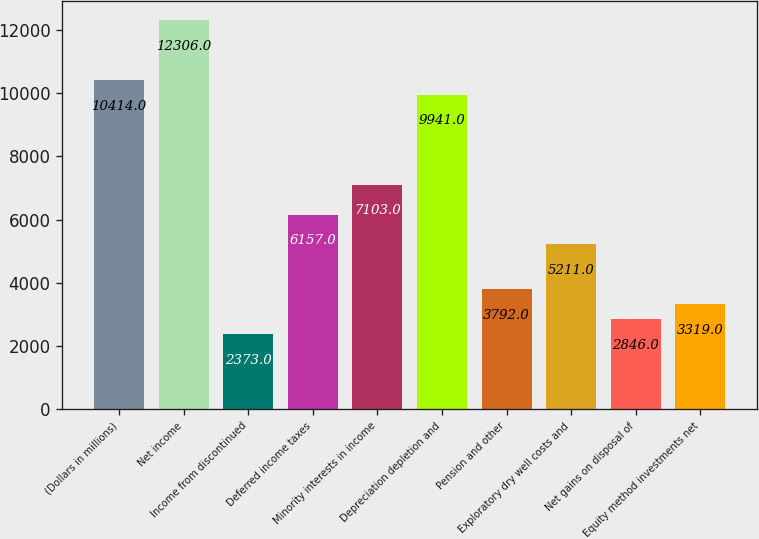Convert chart. <chart><loc_0><loc_0><loc_500><loc_500><bar_chart><fcel>(Dollars in millions)<fcel>Net income<fcel>Income from discontinued<fcel>Deferred income taxes<fcel>Minority interests in income<fcel>Depreciation depletion and<fcel>Pension and other<fcel>Exploratory dry well costs and<fcel>Net gains on disposal of<fcel>Equity method investments net<nl><fcel>10414<fcel>12306<fcel>2373<fcel>6157<fcel>7103<fcel>9941<fcel>3792<fcel>5211<fcel>2846<fcel>3319<nl></chart> 